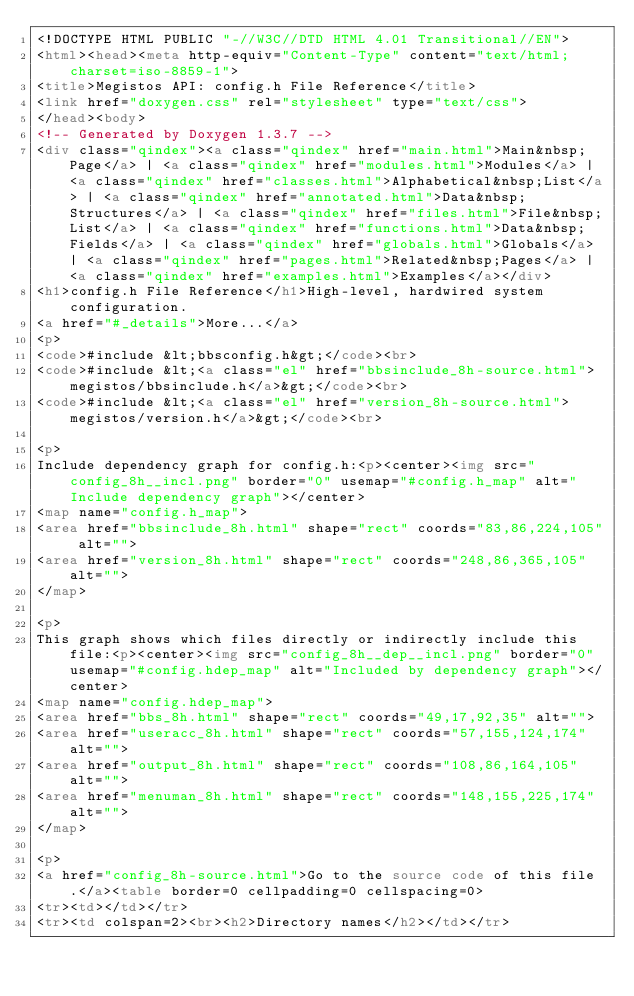<code> <loc_0><loc_0><loc_500><loc_500><_HTML_><!DOCTYPE HTML PUBLIC "-//W3C//DTD HTML 4.01 Transitional//EN">
<html><head><meta http-equiv="Content-Type" content="text/html;charset=iso-8859-1">
<title>Megistos API: config.h File Reference</title>
<link href="doxygen.css" rel="stylesheet" type="text/css">
</head><body>
<!-- Generated by Doxygen 1.3.7 -->
<div class="qindex"><a class="qindex" href="main.html">Main&nbsp;Page</a> | <a class="qindex" href="modules.html">Modules</a> | <a class="qindex" href="classes.html">Alphabetical&nbsp;List</a> | <a class="qindex" href="annotated.html">Data&nbsp;Structures</a> | <a class="qindex" href="files.html">File&nbsp;List</a> | <a class="qindex" href="functions.html">Data&nbsp;Fields</a> | <a class="qindex" href="globals.html">Globals</a> | <a class="qindex" href="pages.html">Related&nbsp;Pages</a> | <a class="qindex" href="examples.html">Examples</a></div>
<h1>config.h File Reference</h1>High-level, hardwired system configuration.  
<a href="#_details">More...</a>
<p>
<code>#include &lt;bbsconfig.h&gt;</code><br>
<code>#include &lt;<a class="el" href="bbsinclude_8h-source.html">megistos/bbsinclude.h</a>&gt;</code><br>
<code>#include &lt;<a class="el" href="version_8h-source.html">megistos/version.h</a>&gt;</code><br>

<p>
Include dependency graph for config.h:<p><center><img src="config_8h__incl.png" border="0" usemap="#config.h_map" alt="Include dependency graph"></center>
<map name="config.h_map">
<area href="bbsinclude_8h.html" shape="rect" coords="83,86,224,105" alt="">
<area href="version_8h.html" shape="rect" coords="248,86,365,105" alt="">
</map>

<p>
This graph shows which files directly or indirectly include this file:<p><center><img src="config_8h__dep__incl.png" border="0" usemap="#config.hdep_map" alt="Included by dependency graph"></center>
<map name="config.hdep_map">
<area href="bbs_8h.html" shape="rect" coords="49,17,92,35" alt="">
<area href="useracc_8h.html" shape="rect" coords="57,155,124,174" alt="">
<area href="output_8h.html" shape="rect" coords="108,86,164,105" alt="">
<area href="menuman_8h.html" shape="rect" coords="148,155,225,174" alt="">
</map>

<p>
<a href="config_8h-source.html">Go to the source code of this file.</a><table border=0 cellpadding=0 cellspacing=0>
<tr><td></td></tr>
<tr><td colspan=2><br><h2>Directory names</h2></td></tr></code> 